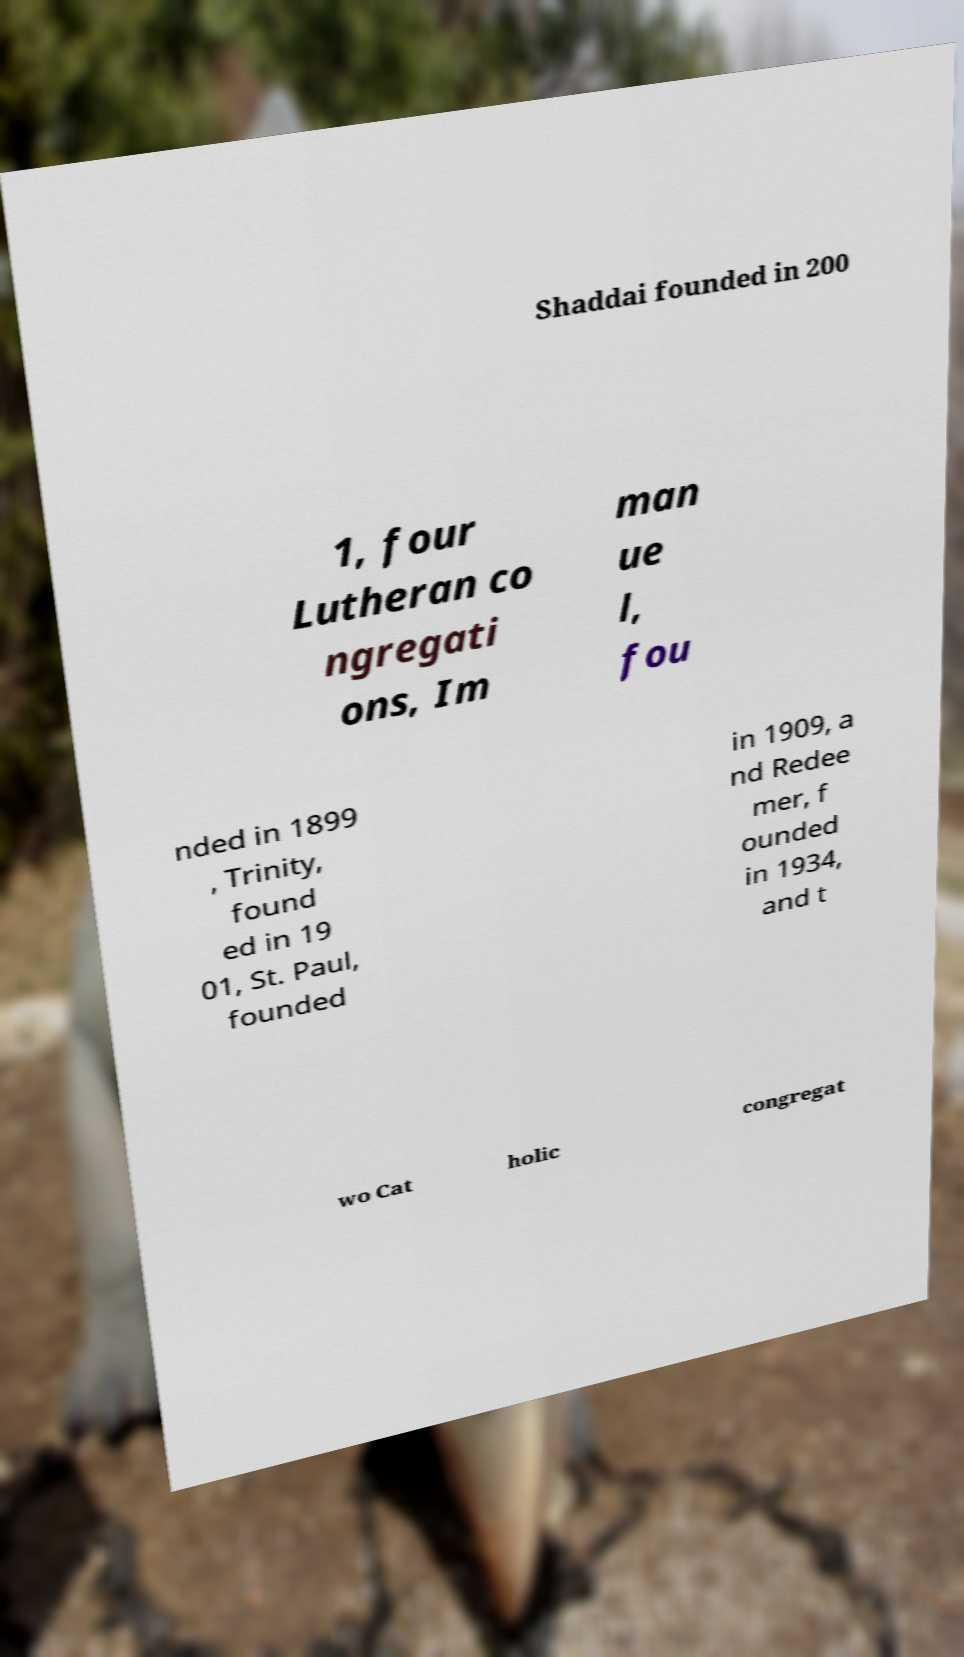Could you extract and type out the text from this image? Shaddai founded in 200 1, four Lutheran co ngregati ons, Im man ue l, fou nded in 1899 , Trinity, found ed in 19 01, St. Paul, founded in 1909, a nd Redee mer, f ounded in 1934, and t wo Cat holic congregat 